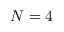<formula> <loc_0><loc_0><loc_500><loc_500>N = 4</formula> 